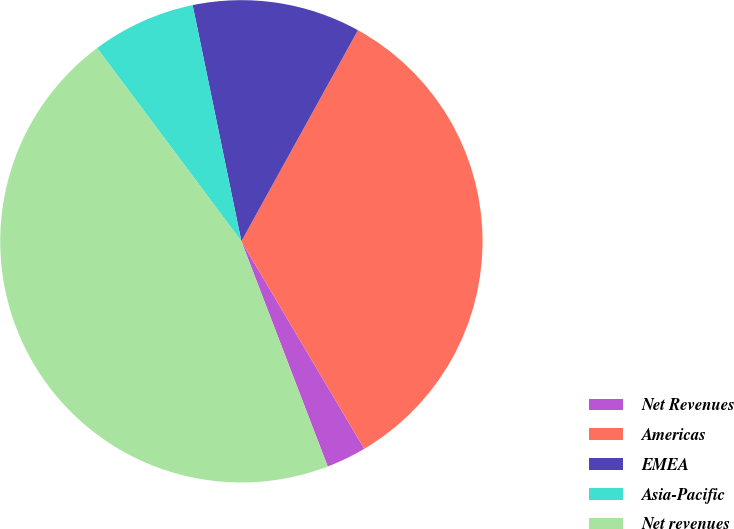Convert chart to OTSL. <chart><loc_0><loc_0><loc_500><loc_500><pie_chart><fcel>Net Revenues<fcel>Americas<fcel>EMEA<fcel>Asia-Pacific<fcel>Net revenues<nl><fcel>2.68%<fcel>33.46%<fcel>11.27%<fcel>6.97%<fcel>45.62%<nl></chart> 